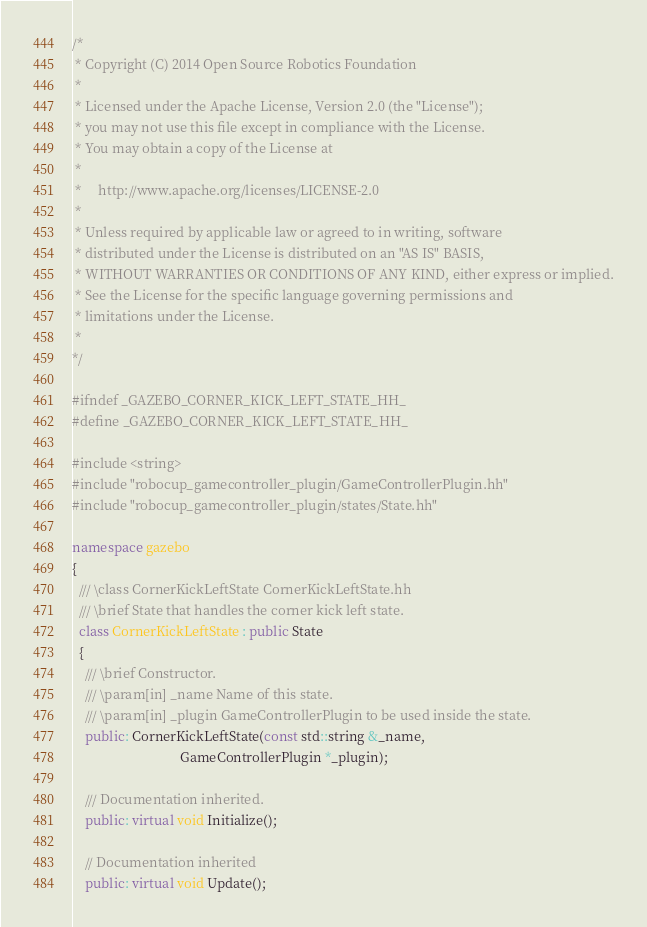Convert code to text. <code><loc_0><loc_0><loc_500><loc_500><_C++_>/*
 * Copyright (C) 2014 Open Source Robotics Foundation
 *
 * Licensed under the Apache License, Version 2.0 (the "License");
 * you may not use this file except in compliance with the License.
 * You may obtain a copy of the License at
 *
 *     http://www.apache.org/licenses/LICENSE-2.0
 *
 * Unless required by applicable law or agreed to in writing, software
 * distributed under the License is distributed on an "AS IS" BASIS,
 * WITHOUT WARRANTIES OR CONDITIONS OF ANY KIND, either express or implied.
 * See the License for the specific language governing permissions and
 * limitations under the License.
 *
*/

#ifndef _GAZEBO_CORNER_KICK_LEFT_STATE_HH_
#define _GAZEBO_CORNER_KICK_LEFT_STATE_HH_

#include <string>
#include "robocup_gamecontroller_plugin/GameControllerPlugin.hh"
#include "robocup_gamecontroller_plugin/states/State.hh"

namespace gazebo
{
  /// \class CornerKickLeftState CornerKickLeftState.hh
  /// \brief State that handles the corner kick left state.
  class CornerKickLeftState : public State
  {
    /// \brief Constructor.
    /// \param[in] _name Name of this state.
    /// \param[in] _plugin GameControllerPlugin to be used inside the state.
    public: CornerKickLeftState(const std::string &_name,
                                GameControllerPlugin *_plugin);

    /// Documentation inherited.
    public: virtual void Initialize();

    // Documentation inherited
    public: virtual void Update();</code> 